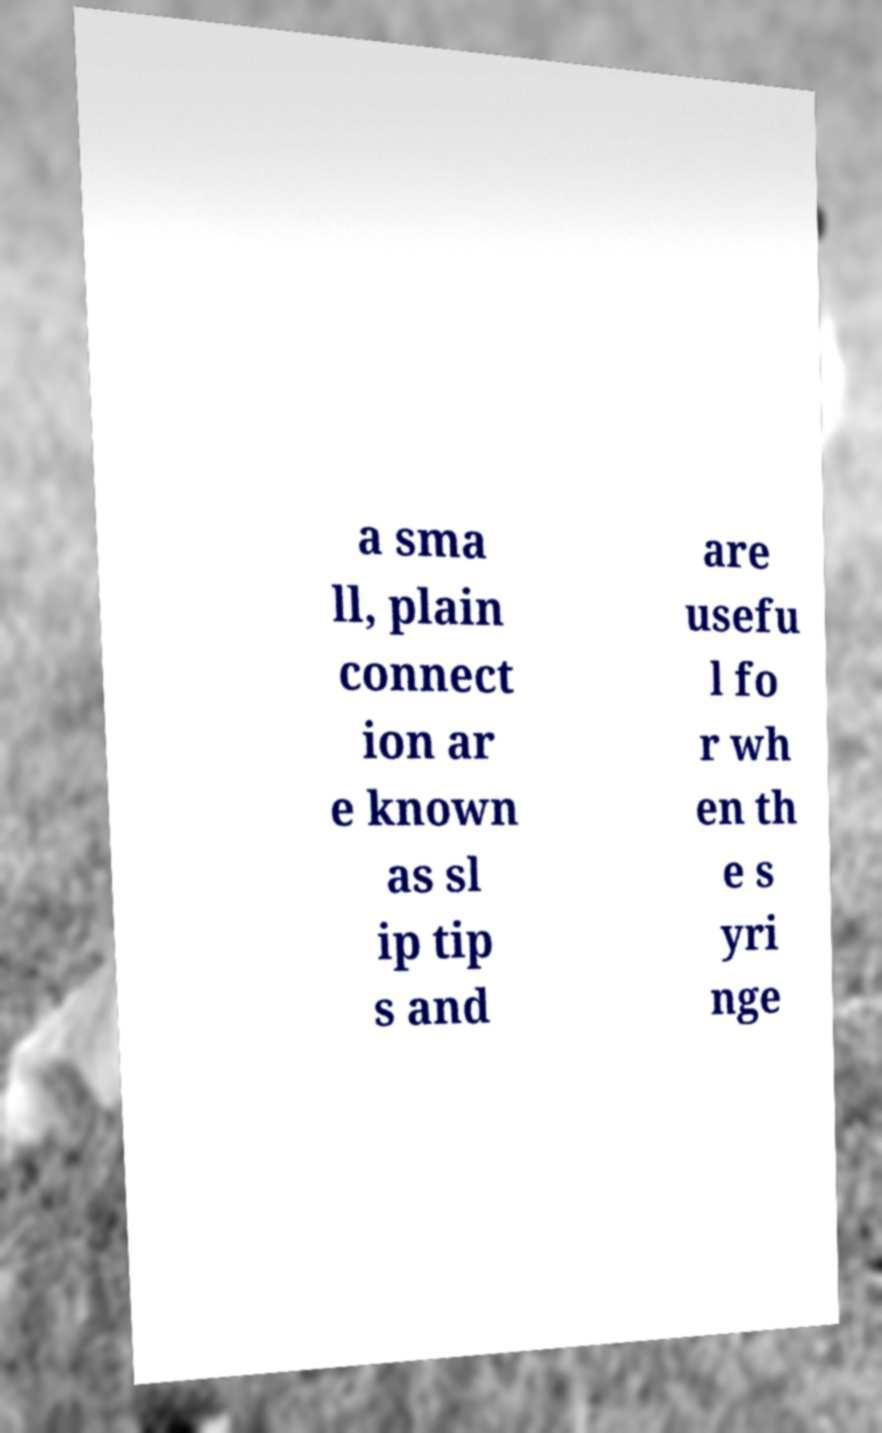Can you read and provide the text displayed in the image?This photo seems to have some interesting text. Can you extract and type it out for me? a sma ll, plain connect ion ar e known as sl ip tip s and are usefu l fo r wh en th e s yri nge 